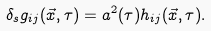<formula> <loc_0><loc_0><loc_500><loc_500>\delta _ { s } g _ { i j } ( \vec { x } , \tau ) = a ^ { 2 } ( \tau ) h _ { i j } ( \vec { x } , \tau ) .</formula> 